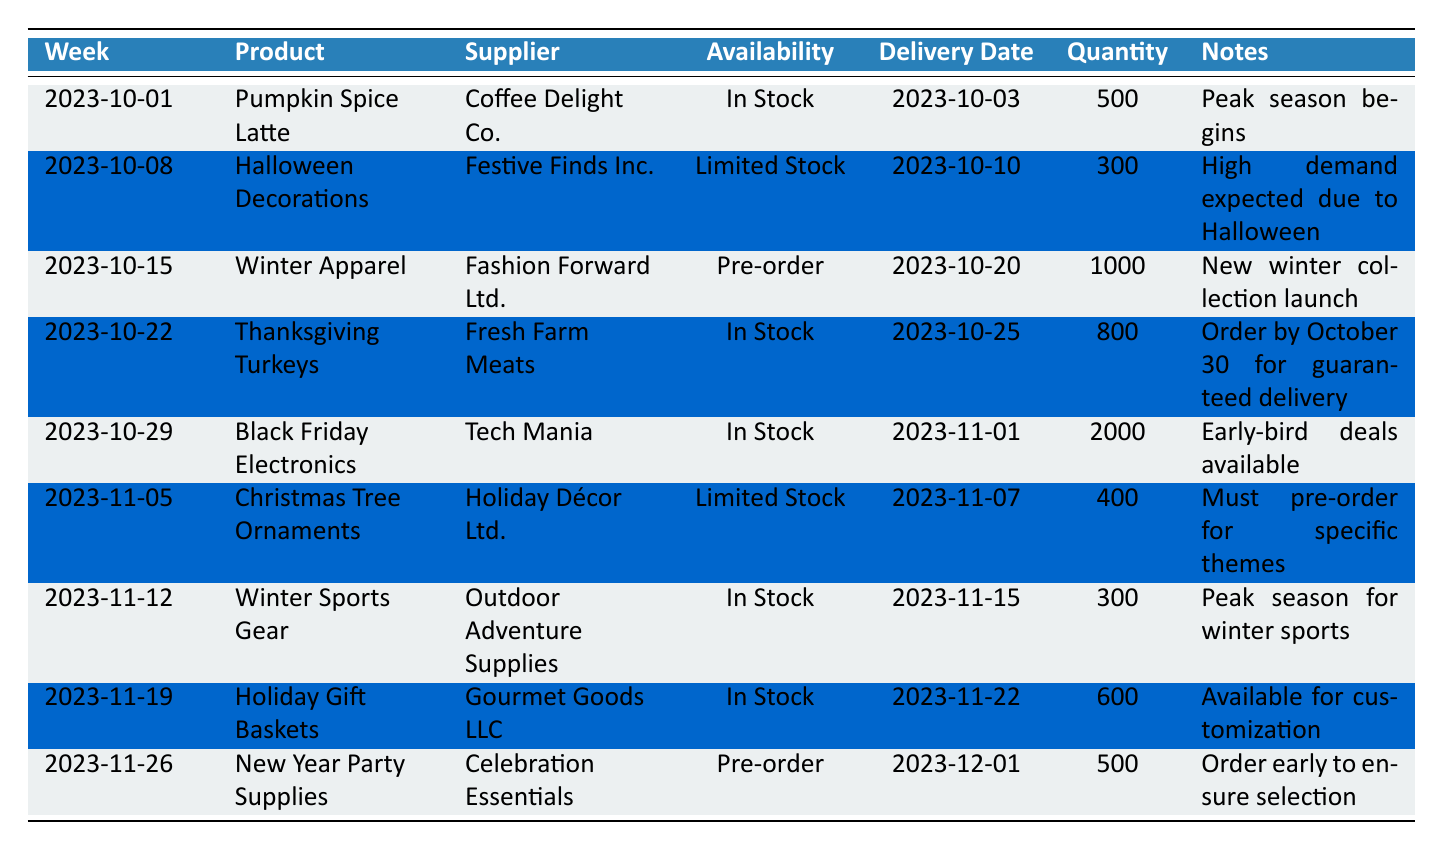What's the availability of "Halloween Decorations"? The table lists the availability of "Halloween Decorations" under the "Availability" column for the week of "2023-10-08," which indicates it is "Limited Stock."
Answer: Limited Stock Which product has the highest quantity available for delivery? By comparing the "Quantity" for each product in the table, "Black Friday Electronics" has the highest quantity listed at 2000.
Answer: Black Friday Electronics Are "Christmas Tree Ornaments" available for immediate delivery? The table shows that "Christmas Tree Ornaments" are marked as "Limited Stock" and are available for delivery on "2023-11-07," indicating they are not immediately available.
Answer: No How many products are available for pre-order in the delivery schedule? The products marked as "Pre-order" in the table are "Winter Apparel" and "New Year Party Supplies." There are 2 products in total.
Answer: 2 What is the delivery date for "Thanksgiving Turkeys"? Referring to the table, the "Thanksgiving Turkeys" product is set to be delivered on "2023-10-25."
Answer: 2023-10-25 Calculate the total quantity of products that are in stock (not on pre-order). Adding the quantities of "Pumpkin Spice Latte," "Thanksgiving Turkeys," "Black Friday Electronics," "Winter Sports Gear," and "Holiday Gift Baskets," the calculation is (500 + 800 + 2000 + 300 + 600) = 4200.
Answer: 4200 Is there a product that must be ordered by a specific date to guarantee availability? Yes, "Thanksgiving Turkeys" require an order by "October 30" for guaranteed delivery, as noted in the "Notes" column.
Answer: Yes What is the average quantity of products in stock? The total quantity of in-stock products includes 500 for "Pumpkin Spice Latte," 800 for "Thanksgiving Turkeys," 2000 for "Black Friday Electronics," 300 for "Winter Sports Gear," and 600 for "Holiday Gift Baskets," totaling 4200. To find the average, divide by the number of in-stock products (5), which gives 4200/5 = 840.
Answer: 840 